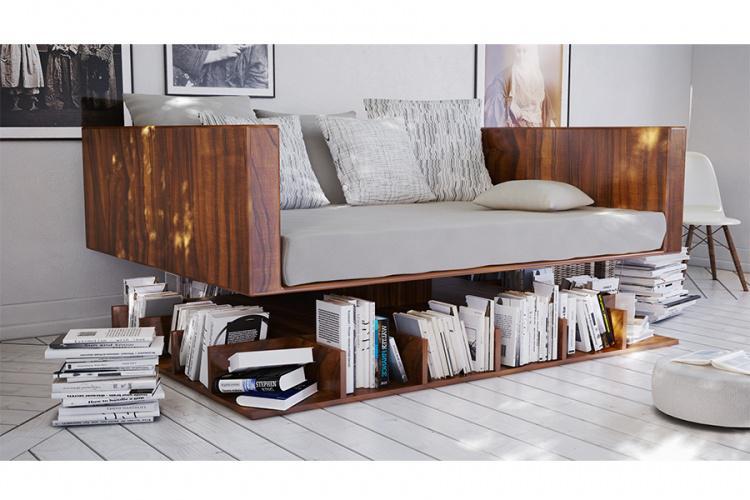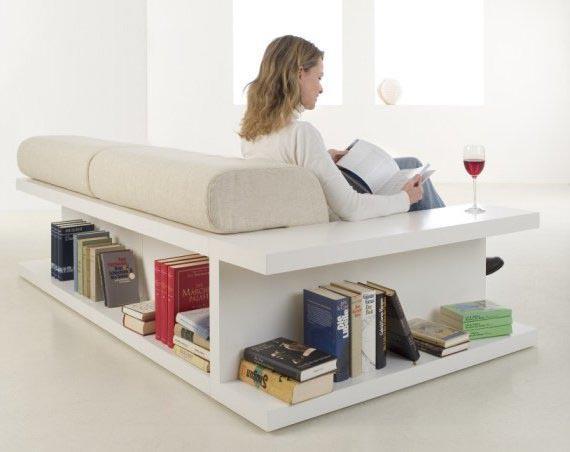The first image is the image on the left, the second image is the image on the right. Analyze the images presented: Is the assertion "There is a stack of three books on the front-most corner of the shelf under the couch in the image on the left." valid? Answer yes or no. Yes. The first image is the image on the left, the second image is the image on the right. Given the left and right images, does the statement "there is a book shelf with a sofa and a rug on the floor" hold true? Answer yes or no. No. 